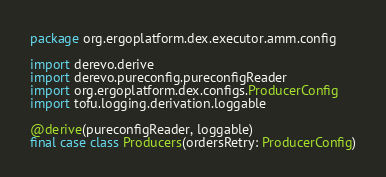Convert code to text. <code><loc_0><loc_0><loc_500><loc_500><_Scala_>package org.ergoplatform.dex.executor.amm.config

import derevo.derive
import derevo.pureconfig.pureconfigReader
import org.ergoplatform.dex.configs.ProducerConfig
import tofu.logging.derivation.loggable

@derive(pureconfigReader, loggable)
final case class Producers(ordersRetry: ProducerConfig)
</code> 